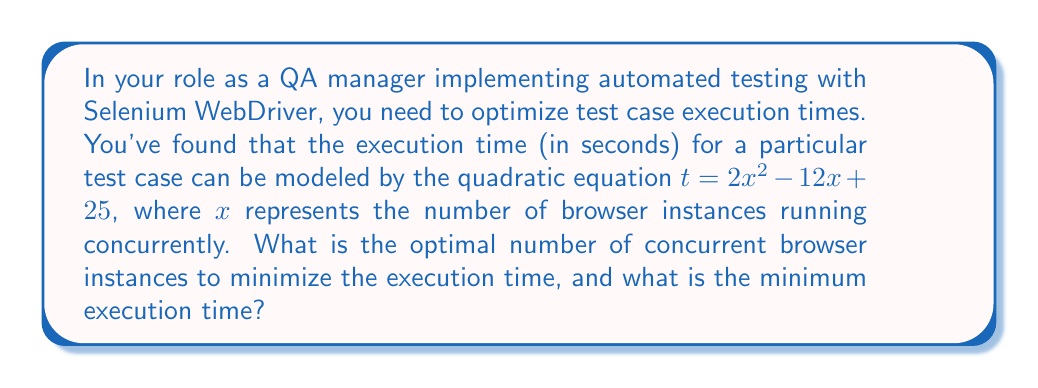What is the answer to this math problem? To find the optimal number of concurrent browser instances and the minimum execution time, we need to follow these steps:

1. Recognize that this is a quadratic equation in the form $f(x) = ax^2 + bx + c$, where:
   $a = 2$
   $b = -12$
   $c = 25$

2. The minimum point of a quadratic function occurs at the vertex of the parabola. We can find the x-coordinate of the vertex using the formula: $x = -\frac{b}{2a}$

3. Calculate the x-coordinate of the vertex:
   $x = -\frac{-12}{2(2)} = \frac{12}{4} = 3$

4. This means the optimal number of concurrent browser instances is 3.

5. To find the minimum execution time, we substitute x = 3 into the original equation:
   $t = 2(3)^2 - 12(3) + 25$
   $t = 2(9) - 36 + 25$
   $t = 18 - 36 + 25$
   $t = 7$

Therefore, the minimum execution time is 7 seconds.
Answer: 3 instances; 7 seconds 